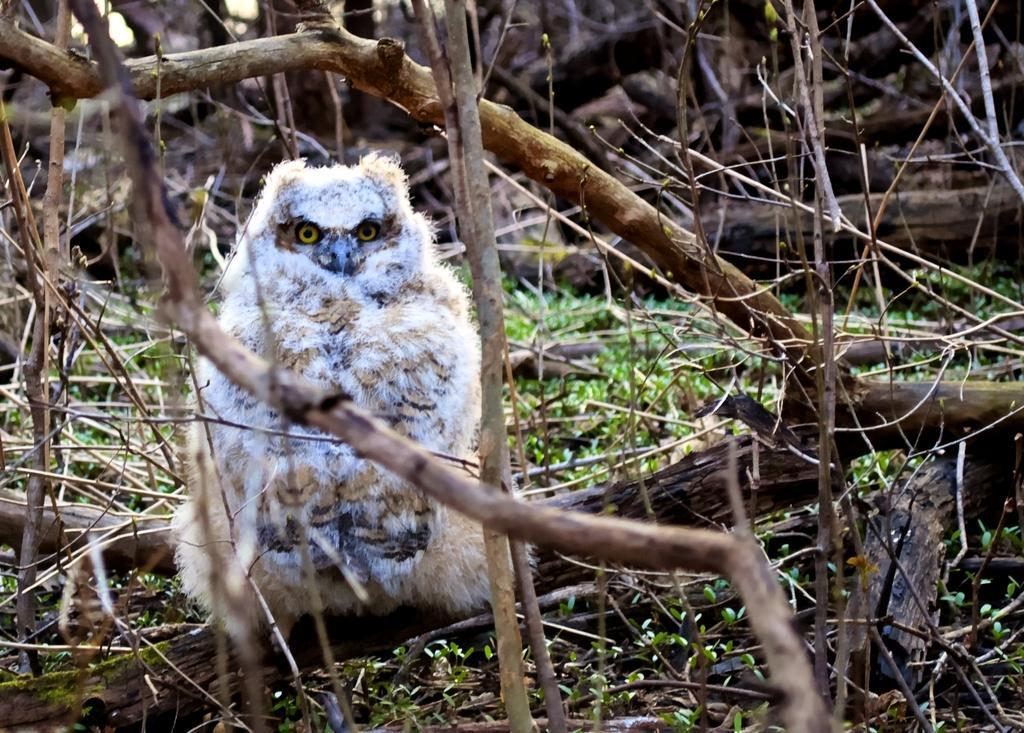Please provide a concise description of this image. In this picture we can see a bird, dry tree branches and grass. 